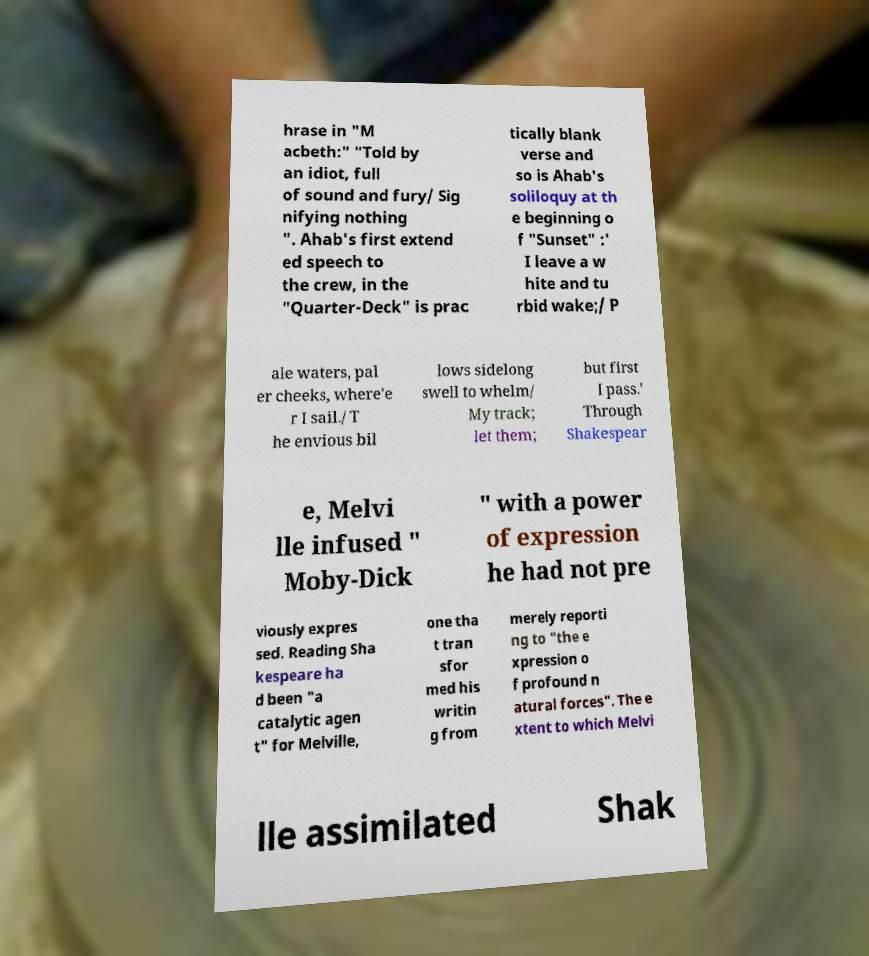For documentation purposes, I need the text within this image transcribed. Could you provide that? hrase in "M acbeth:" "Told by an idiot, full of sound and fury/ Sig nifying nothing ". Ahab's first extend ed speech to the crew, in the "Quarter-Deck" is prac tically blank verse and so is Ahab's soliloquy at th e beginning o f "Sunset" :' I leave a w hite and tu rbid wake;/ P ale waters, pal er cheeks, where'e r I sail./ T he envious bil lows sidelong swell to whelm/ My track; let them; but first I pass.' Through Shakespear e, Melvi lle infused " Moby-Dick " with a power of expression he had not pre viously expres sed. Reading Sha kespeare ha d been "a catalytic agen t" for Melville, one tha t tran sfor med his writin g from merely reporti ng to "the e xpression o f profound n atural forces". The e xtent to which Melvi lle assimilated Shak 